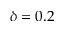<formula> <loc_0><loc_0><loc_500><loc_500>\delta = 0 . 2</formula> 